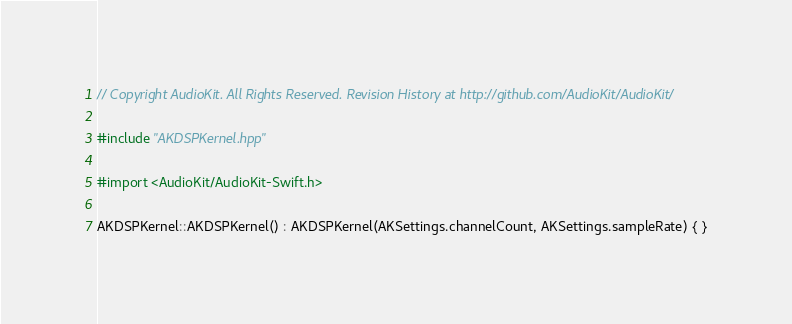Convert code to text. <code><loc_0><loc_0><loc_500><loc_500><_ObjectiveC_>// Copyright AudioKit. All Rights Reserved. Revision History at http://github.com/AudioKit/AudioKit/

#include "AKDSPKernel.hpp"

#import <AudioKit/AudioKit-Swift.h>

AKDSPKernel::AKDSPKernel() : AKDSPKernel(AKSettings.channelCount, AKSettings.sampleRate) { }
</code> 